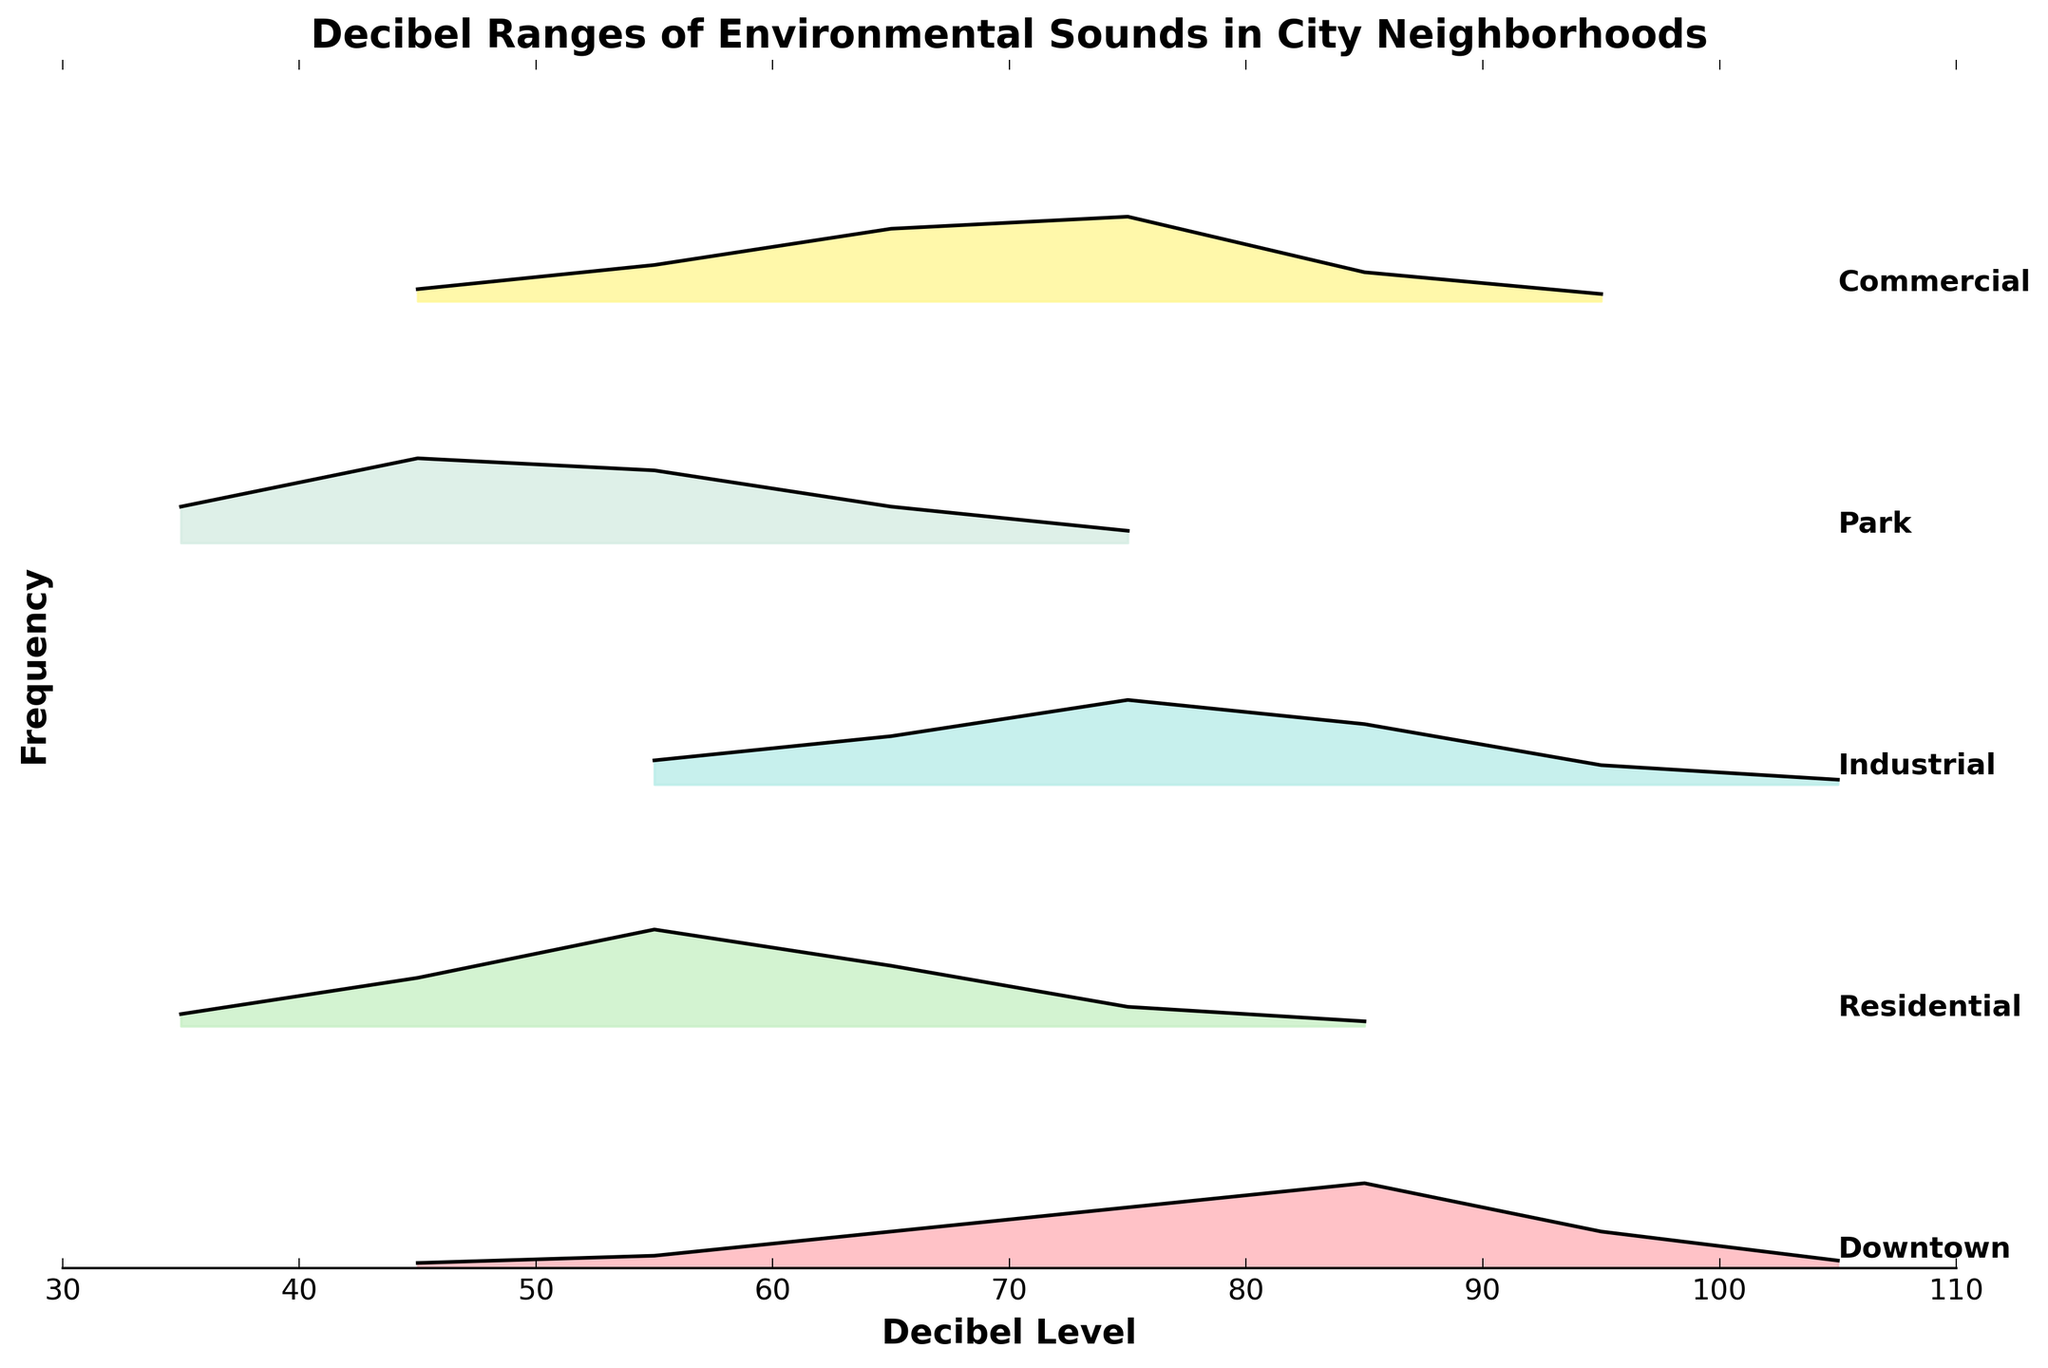what's the title of the plot? The title of the plot is displayed at the top and it reads 'Decibel Ranges of Environmental Sounds in City Neighborhoods'.
Answer: Decibel Ranges of Environmental Sounds in City Neighborhoods what's the highest frequency recorded in Downtown? Look at the highest point on the plot for Downtown, marked by the curve and filled area. The highest frequency is at a decibel level of 85, reaching a frequency of 0.35.
Answer: 0.35 Which neighborhood has the lowest recorded decibel level? Identify the starting decibel levels on the x-axis for each neighborhood. The lowest value is 35 decibels and is found in both the Residential and Park neighborhoods.
Answer: Residential and Park How does the decibel level in Residential areas at 55 compare to that in Downtown at 55? Compare the height of the plots representing the frequencies at 55 decibels for both neighborhoods. For Residential, the frequency is 0.40, while for Downtown, it's 0.05.
Answer: Residential is higher What's the average decibel level with the highest frequency in Downtown? For Downtown, the highest frequency is at 85 decibels with a frequency of 0.35. Since there's only one such value in this context, the average is simply the decibel level itself.
Answer: 85 Compare the decibel levels at peak frequencies of Industrial and Commercial areas. The peak frequency for Industrial is at 75 decibels with a frequency of 0.35. The peak for Commercial is also at 75 decibels with a frequency of 0.35.
Answer: Same at 75 decibels What is the range of the decibel levels in Park? Examine the x-axis values that are spanned by the Park neighborhood's plot. The decibel range starts from 35 and ends at 75.
Answer: 35 to 75 Which neighborhoods have decibel levels peaking above 75 decibels? Check each neighborhood's plot for peaks above 75 decibels. Downtown (85 decibels), Industrial (85 decibels), and Commercial (75 decibels) have peaks above 75.
Answer: Downtown, Industrial, and Commercial What is the common highest decibel level across all neighborhoods? Look at the far right end of the x-axis for all neighborhoods to determine their highest levels. Both Downtown, Industrial, and Commercial have plots extending to 105 decibels.
Answer: 105 